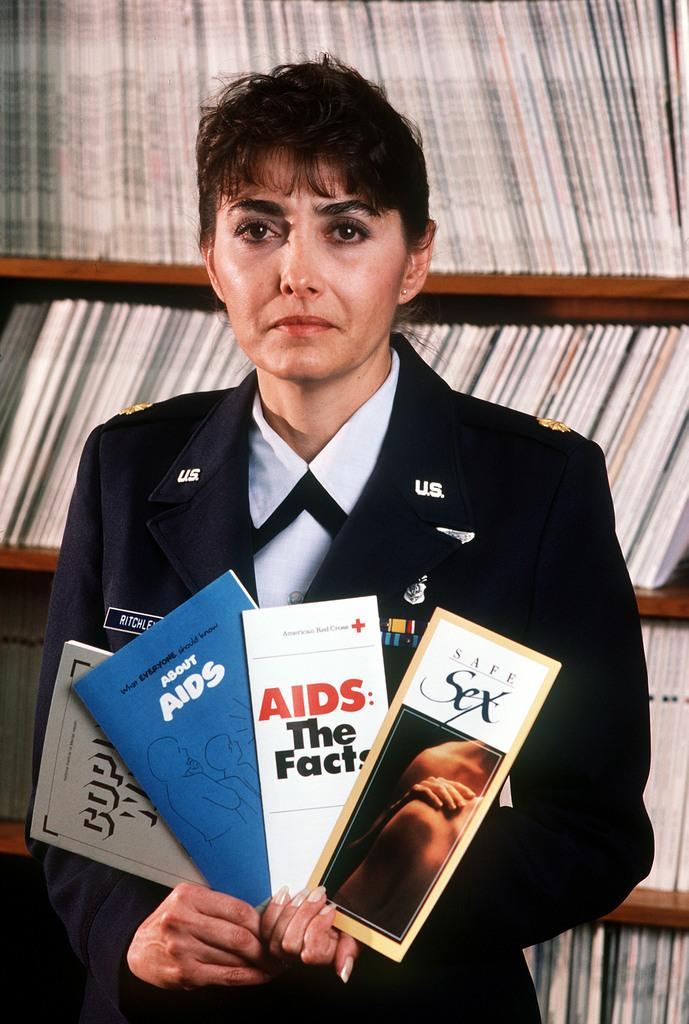Who is the main subject in the image? There is a woman in the center of the image. What is the woman holding in the image? The woman is holding different books. Can you describe the background of the image? There are many books in the background of the image, presumably in a rack. What type of shirt is the woman wearing in the image? The provided facts do not mention the woman's shirt, so we cannot determine the type of shirt she is wearing. 